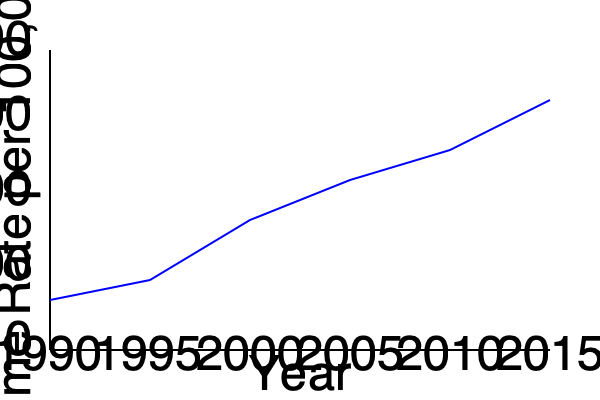As a former journalist who has reported on criminal cases, analyze the trend in crime rates shown in the graph. What percentage decrease in crime rate occurred between 1990 and 2015? Round your answer to the nearest whole number. To calculate the percentage decrease in crime rate between 1990 and 2015, we need to follow these steps:

1. Identify the crime rates for 1990 and 2015:
   - 1990 (start of graph): approximately 5000 per 100,000
   - 2015 (end of graph): approximately 2500 per 100,000

2. Calculate the decrease in crime rate:
   $\text{Decrease} = 5000 - 2500 = 2500$ per 100,000

3. Calculate the percentage decrease:
   $\text{Percentage decrease} = \frac{\text{Decrease}}{\text{Original value}} \times 100\%$
   $= \frac{2500}{5000} \times 100\% = 0.5 \times 100\% = 50\%$

4. Round to the nearest whole number:
   50% (no rounding needed in this case)

Therefore, the crime rate decreased by 50% between 1990 and 2015.
Answer: 50% 